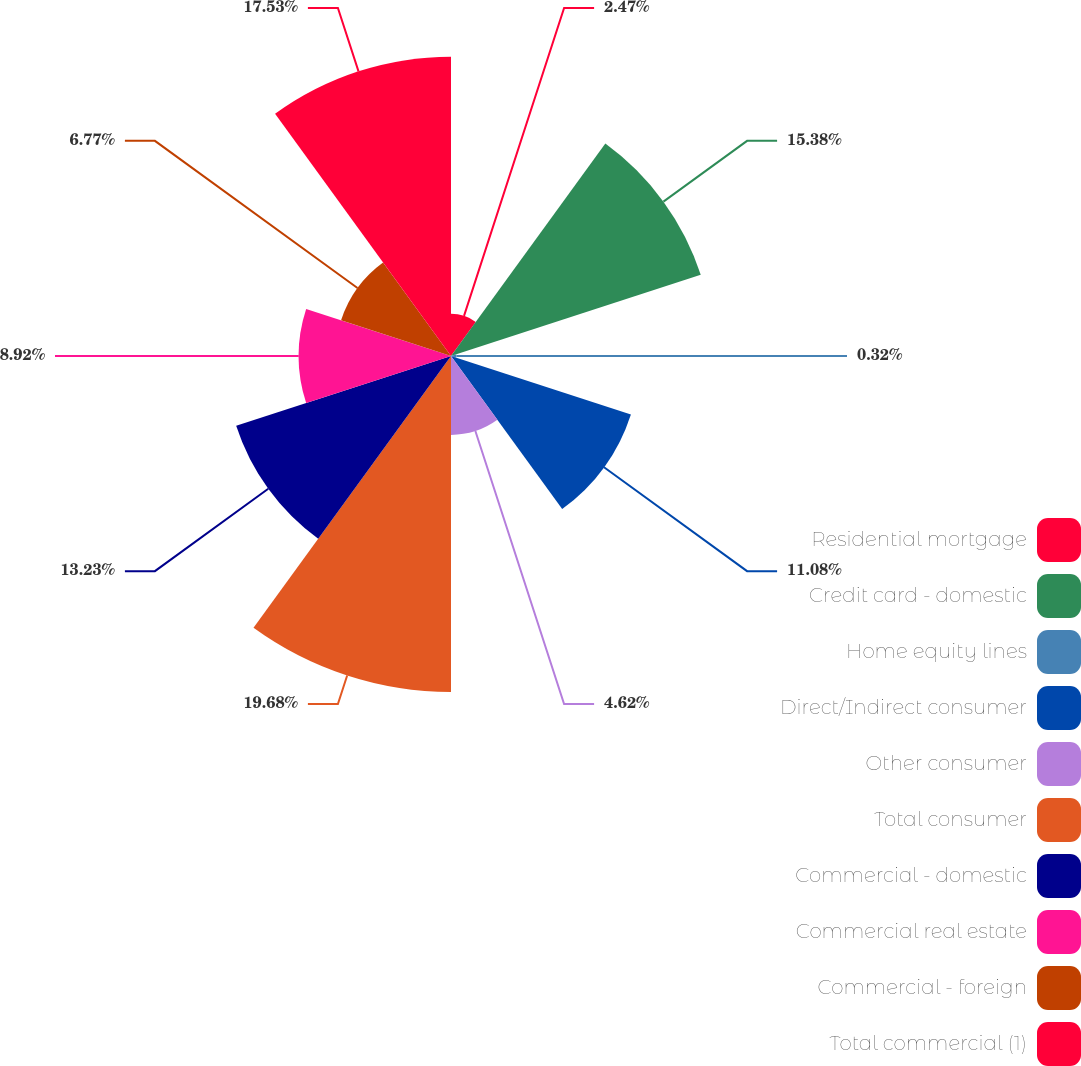<chart> <loc_0><loc_0><loc_500><loc_500><pie_chart><fcel>Residential mortgage<fcel>Credit card - domestic<fcel>Home equity lines<fcel>Direct/Indirect consumer<fcel>Other consumer<fcel>Total consumer<fcel>Commercial - domestic<fcel>Commercial real estate<fcel>Commercial - foreign<fcel>Total commercial (1)<nl><fcel>2.47%<fcel>15.38%<fcel>0.32%<fcel>11.08%<fcel>4.62%<fcel>19.68%<fcel>13.23%<fcel>8.92%<fcel>6.77%<fcel>17.53%<nl></chart> 